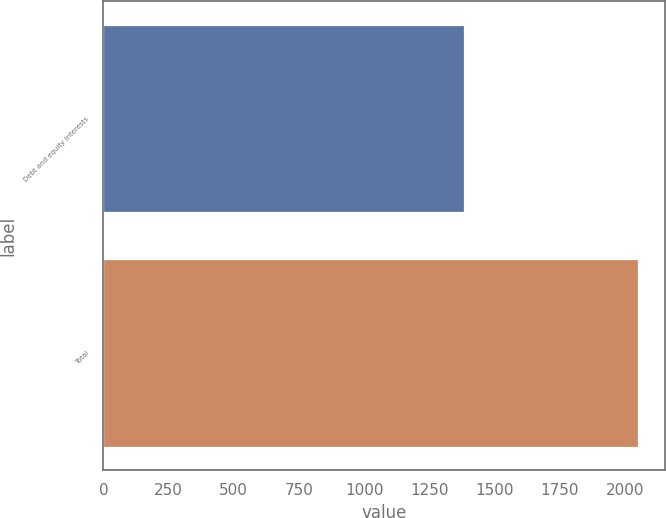Convert chart to OTSL. <chart><loc_0><loc_0><loc_500><loc_500><bar_chart><fcel>Debt and equity interests<fcel>Total<nl><fcel>1384<fcel>2052<nl></chart> 